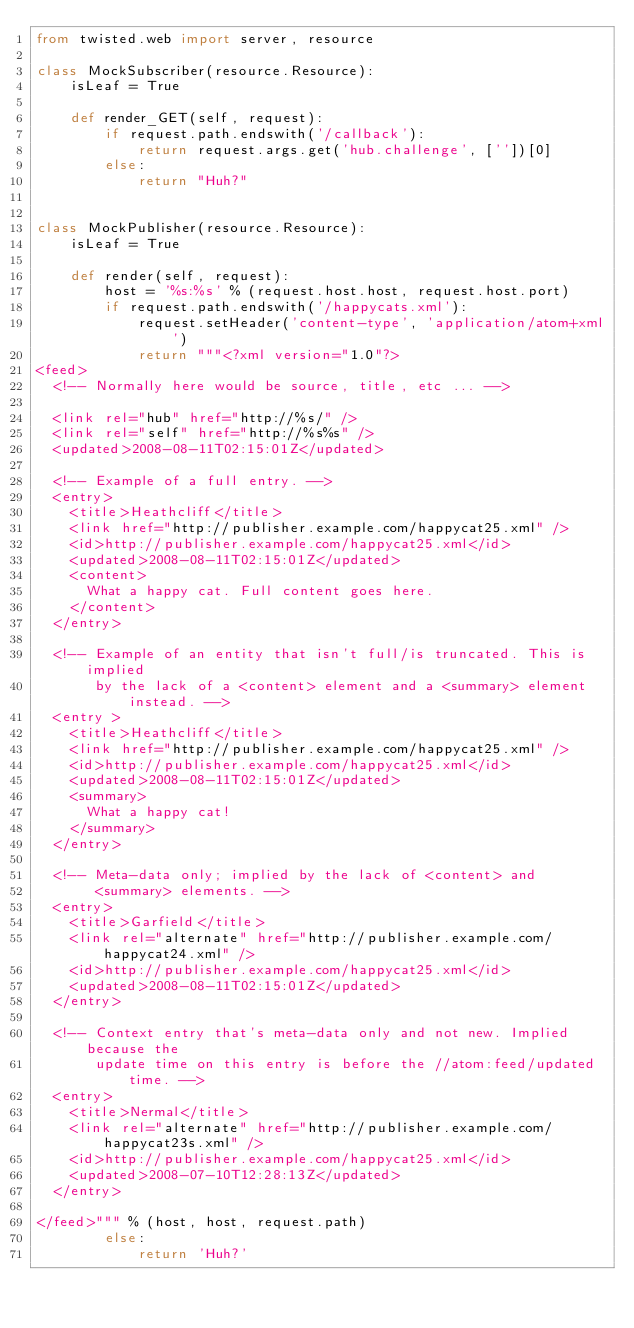<code> <loc_0><loc_0><loc_500><loc_500><_Python_>from twisted.web import server, resource

class MockSubscriber(resource.Resource):
    isLeaf = True
    
    def render_GET(self, request):
        if request.path.endswith('/callback'):
            return request.args.get('hub.challenge', [''])[0]
        else:
            return "Huh?"
        

class MockPublisher(resource.Resource):
    isLeaf = True
    
    def render(self, request):
        host = '%s:%s' % (request.host.host, request.host.port)
        if request.path.endswith('/happycats.xml'):
            request.setHeader('content-type', 'application/atom+xml')
            return """<?xml version="1.0"?>
<feed>
  <!-- Normally here would be source, title, etc ... -->

  <link rel="hub" href="http://%s/" />
  <link rel="self" href="http://%s%s" />
  <updated>2008-08-11T02:15:01Z</updated>

  <!-- Example of a full entry. -->
  <entry>
    <title>Heathcliff</title>
    <link href="http://publisher.example.com/happycat25.xml" />
    <id>http://publisher.example.com/happycat25.xml</id>
    <updated>2008-08-11T02:15:01Z</updated>
    <content>
      What a happy cat. Full content goes here.
    </content>
  </entry>

  <!-- Example of an entity that isn't full/is truncated. This is implied
       by the lack of a <content> element and a <summary> element instead. -->
  <entry >
    <title>Heathcliff</title>
    <link href="http://publisher.example.com/happycat25.xml" />
    <id>http://publisher.example.com/happycat25.xml</id>
    <updated>2008-08-11T02:15:01Z</updated>
    <summary>
      What a happy cat!
    </summary>
  </entry>

  <!-- Meta-data only; implied by the lack of <content> and
       <summary> elements. -->
  <entry>
    <title>Garfield</title>
    <link rel="alternate" href="http://publisher.example.com/happycat24.xml" />
    <id>http://publisher.example.com/happycat25.xml</id>
    <updated>2008-08-11T02:15:01Z</updated>
  </entry>

  <!-- Context entry that's meta-data only and not new. Implied because the
       update time on this entry is before the //atom:feed/updated time. -->
  <entry>
    <title>Nermal</title>
    <link rel="alternate" href="http://publisher.example.com/happycat23s.xml" />
    <id>http://publisher.example.com/happycat25.xml</id>
    <updated>2008-07-10T12:28:13Z</updated>
  </entry>

</feed>""" % (host, host, request.path)
        else:
            return 'Huh?'</code> 